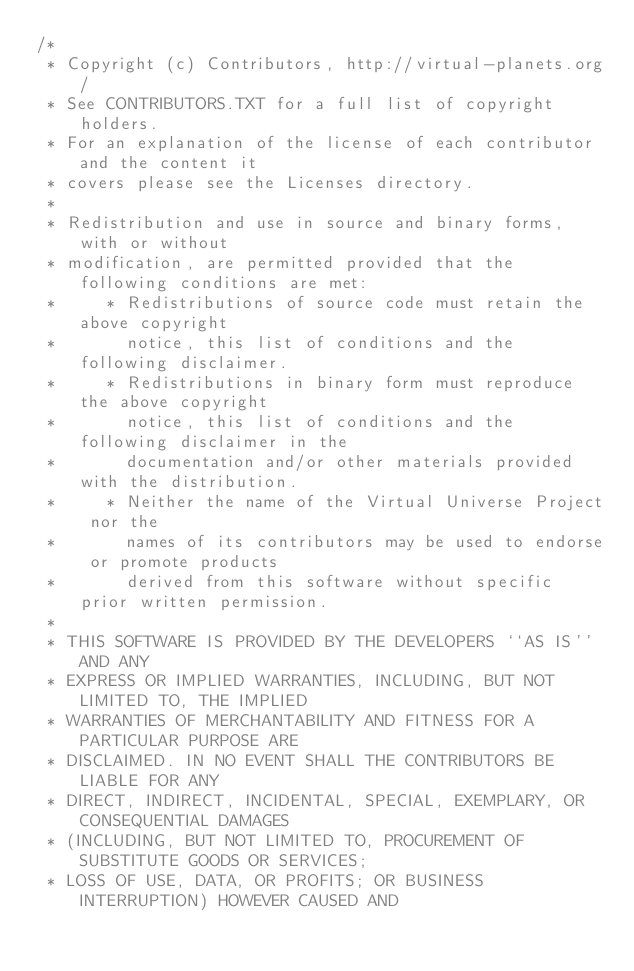Convert code to text. <code><loc_0><loc_0><loc_500><loc_500><_C#_>/*
 * Copyright (c) Contributors, http://virtual-planets.org/
 * See CONTRIBUTORS.TXT for a full list of copyright holders.
 * For an explanation of the license of each contributor and the content it 
 * covers please see the Licenses directory.
 *
 * Redistribution and use in source and binary forms, with or without
 * modification, are permitted provided that the following conditions are met:
 *     * Redistributions of source code must retain the above copyright
 *       notice, this list of conditions and the following disclaimer.
 *     * Redistributions in binary form must reproduce the above copyright
 *       notice, this list of conditions and the following disclaimer in the
 *       documentation and/or other materials provided with the distribution.
 *     * Neither the name of the Virtual Universe Project nor the
 *       names of its contributors may be used to endorse or promote products
 *       derived from this software without specific prior written permission.
 *
 * THIS SOFTWARE IS PROVIDED BY THE DEVELOPERS ``AS IS'' AND ANY
 * EXPRESS OR IMPLIED WARRANTIES, INCLUDING, BUT NOT LIMITED TO, THE IMPLIED
 * WARRANTIES OF MERCHANTABILITY AND FITNESS FOR A PARTICULAR PURPOSE ARE
 * DISCLAIMED. IN NO EVENT SHALL THE CONTRIBUTORS BE LIABLE FOR ANY
 * DIRECT, INDIRECT, INCIDENTAL, SPECIAL, EXEMPLARY, OR CONSEQUENTIAL DAMAGES
 * (INCLUDING, BUT NOT LIMITED TO, PROCUREMENT OF SUBSTITUTE GOODS OR SERVICES;
 * LOSS OF USE, DATA, OR PROFITS; OR BUSINESS INTERRUPTION) HOWEVER CAUSED AND</code> 